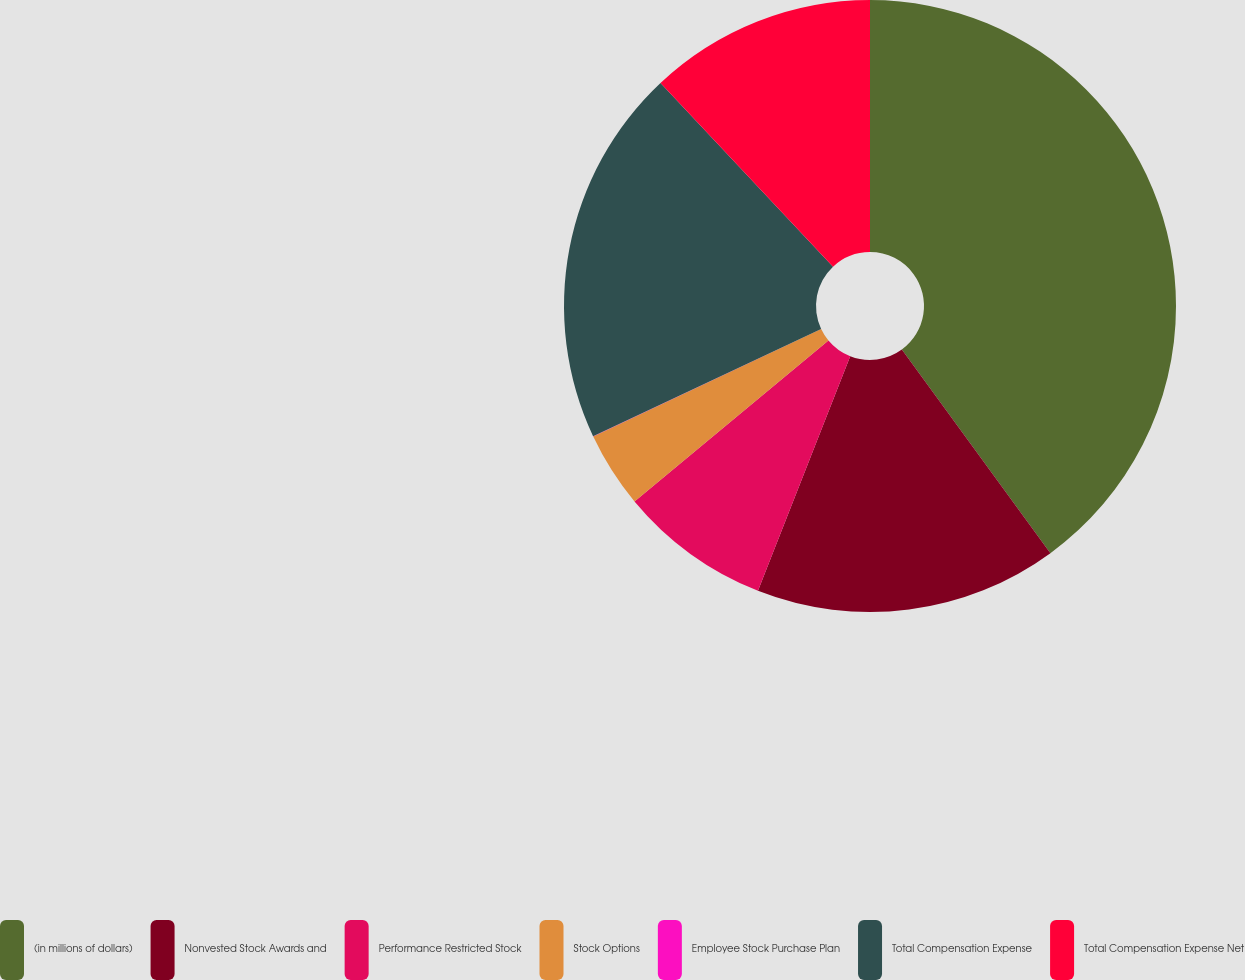Convert chart to OTSL. <chart><loc_0><loc_0><loc_500><loc_500><pie_chart><fcel>(in millions of dollars)<fcel>Nonvested Stock Awards and<fcel>Performance Restricted Stock<fcel>Stock Options<fcel>Employee Stock Purchase Plan<fcel>Total Compensation Expense<fcel>Total Compensation Expense Net<nl><fcel>39.96%<fcel>16.0%<fcel>8.01%<fcel>4.01%<fcel>0.02%<fcel>19.99%<fcel>12.0%<nl></chart> 